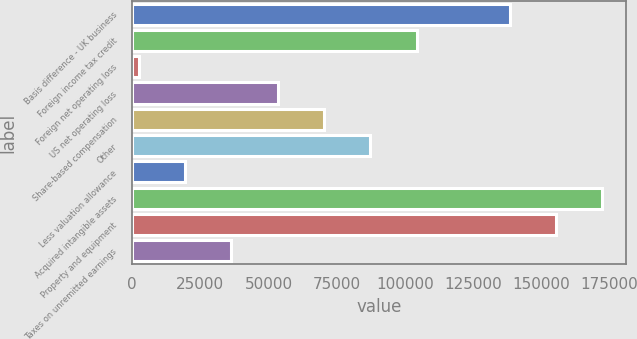Convert chart to OTSL. <chart><loc_0><loc_0><loc_500><loc_500><bar_chart><fcel>Basis difference - UK business<fcel>Foreign income tax credit<fcel>Foreign net operating loss<fcel>US net operating loss<fcel>Share-based compensation<fcel>Other<fcel>Less valuation allowance<fcel>Acquired intangible assets<fcel>Property and equipment<fcel>Taxes on unremitted earnings<nl><fcel>138408<fcel>104388<fcel>2330<fcel>53359.1<fcel>70368.8<fcel>87378.5<fcel>19339.7<fcel>172427<fcel>155417<fcel>36349.4<nl></chart> 